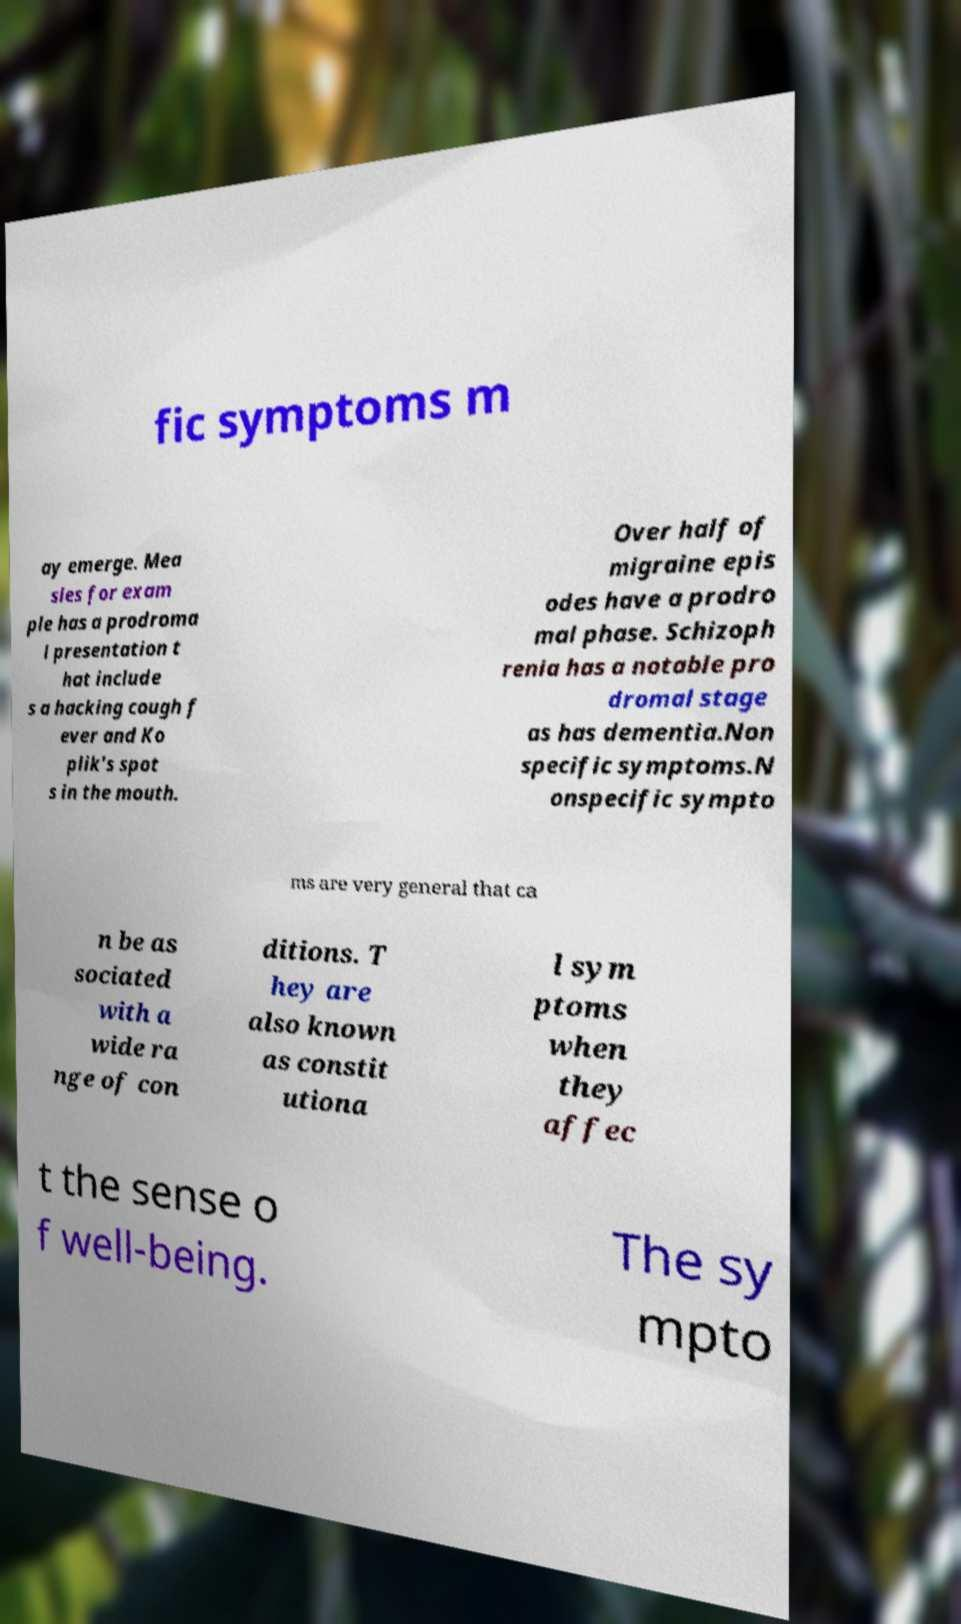For documentation purposes, I need the text within this image transcribed. Could you provide that? fic symptoms m ay emerge. Mea sles for exam ple has a prodroma l presentation t hat include s a hacking cough f ever and Ko plik's spot s in the mouth. Over half of migraine epis odes have a prodro mal phase. Schizoph renia has a notable pro dromal stage as has dementia.Non specific symptoms.N onspecific sympto ms are very general that ca n be as sociated with a wide ra nge of con ditions. T hey are also known as constit utiona l sym ptoms when they affec t the sense o f well-being. The sy mpto 